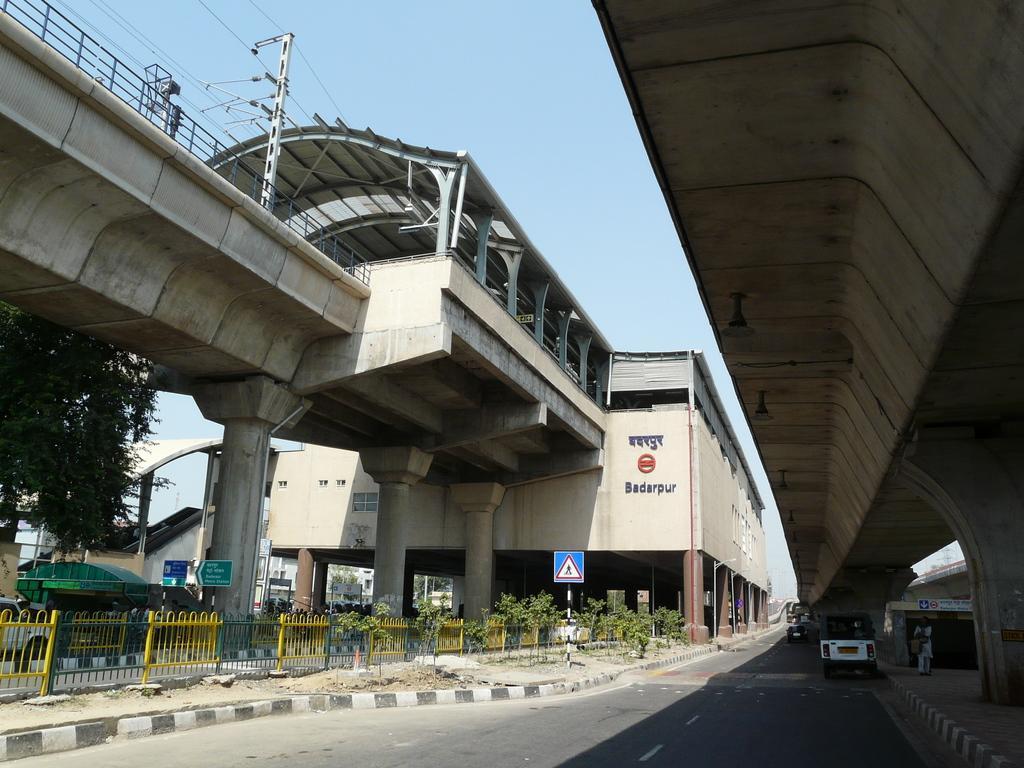Describe this image in one or two sentences. In this image there is a building having a bridge. Right side there is a flyover. Few vehicles are on the road. Left side there is a fence on the pavement. There are few plants. There is a board attached to the pole which is on the pavement. Behind the fence there are few vehicles on the road. Left side there is a tree. Background there is sky. A person is standing at the right side of the image. 